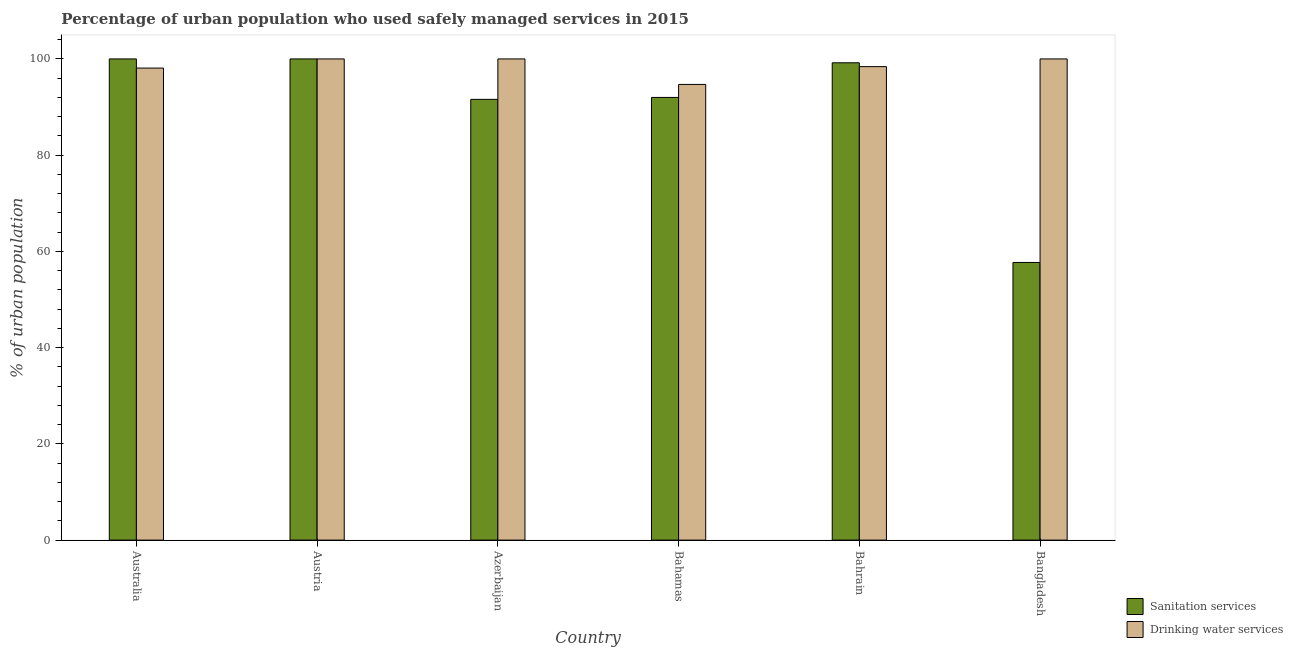How many groups of bars are there?
Make the answer very short. 6. How many bars are there on the 3rd tick from the left?
Offer a very short reply. 2. How many bars are there on the 5th tick from the right?
Give a very brief answer. 2. What is the label of the 3rd group of bars from the left?
Provide a succinct answer. Azerbaijan. What is the percentage of urban population who used drinking water services in Austria?
Offer a very short reply. 100. Across all countries, what is the maximum percentage of urban population who used sanitation services?
Give a very brief answer. 100. Across all countries, what is the minimum percentage of urban population who used sanitation services?
Provide a short and direct response. 57.7. In which country was the percentage of urban population who used sanitation services maximum?
Your answer should be compact. Australia. What is the total percentage of urban population who used sanitation services in the graph?
Ensure brevity in your answer.  540.5. What is the difference between the percentage of urban population who used sanitation services in Australia and that in Bangladesh?
Your answer should be compact. 42.3. What is the difference between the percentage of urban population who used drinking water services in Bangladesh and the percentage of urban population who used sanitation services in Bahamas?
Provide a short and direct response. 8. What is the average percentage of urban population who used sanitation services per country?
Provide a short and direct response. 90.08. What is the difference between the percentage of urban population who used sanitation services and percentage of urban population who used drinking water services in Austria?
Keep it short and to the point. 0. In how many countries, is the percentage of urban population who used drinking water services greater than 20 %?
Make the answer very short. 6. What is the ratio of the percentage of urban population who used sanitation services in Austria to that in Azerbaijan?
Your answer should be very brief. 1.09. Is the percentage of urban population who used sanitation services in Azerbaijan less than that in Bahrain?
Keep it short and to the point. Yes. What is the difference between the highest and the second highest percentage of urban population who used drinking water services?
Your answer should be very brief. 0. What is the difference between the highest and the lowest percentage of urban population who used drinking water services?
Your answer should be compact. 5.3. In how many countries, is the percentage of urban population who used drinking water services greater than the average percentage of urban population who used drinking water services taken over all countries?
Your answer should be very brief. 3. Is the sum of the percentage of urban population who used drinking water services in Australia and Bahamas greater than the maximum percentage of urban population who used sanitation services across all countries?
Your response must be concise. Yes. What does the 2nd bar from the left in Bahrain represents?
Ensure brevity in your answer.  Drinking water services. What does the 1st bar from the right in Azerbaijan represents?
Offer a very short reply. Drinking water services. Are all the bars in the graph horizontal?
Offer a very short reply. No. How many countries are there in the graph?
Provide a succinct answer. 6. What is the difference between two consecutive major ticks on the Y-axis?
Provide a succinct answer. 20. Are the values on the major ticks of Y-axis written in scientific E-notation?
Make the answer very short. No. Where does the legend appear in the graph?
Offer a very short reply. Bottom right. What is the title of the graph?
Your response must be concise. Percentage of urban population who used safely managed services in 2015. Does "Highest 10% of population" appear as one of the legend labels in the graph?
Provide a succinct answer. No. What is the label or title of the X-axis?
Keep it short and to the point. Country. What is the label or title of the Y-axis?
Keep it short and to the point. % of urban population. What is the % of urban population in Drinking water services in Australia?
Provide a succinct answer. 98.1. What is the % of urban population of Sanitation services in Austria?
Make the answer very short. 100. What is the % of urban population in Drinking water services in Austria?
Keep it short and to the point. 100. What is the % of urban population of Sanitation services in Azerbaijan?
Provide a succinct answer. 91.6. What is the % of urban population in Drinking water services in Azerbaijan?
Offer a very short reply. 100. What is the % of urban population of Sanitation services in Bahamas?
Make the answer very short. 92. What is the % of urban population in Drinking water services in Bahamas?
Offer a terse response. 94.7. What is the % of urban population in Sanitation services in Bahrain?
Give a very brief answer. 99.2. What is the % of urban population of Drinking water services in Bahrain?
Your response must be concise. 98.4. What is the % of urban population in Sanitation services in Bangladesh?
Provide a short and direct response. 57.7. What is the % of urban population of Drinking water services in Bangladesh?
Offer a very short reply. 100. Across all countries, what is the minimum % of urban population of Sanitation services?
Ensure brevity in your answer.  57.7. Across all countries, what is the minimum % of urban population in Drinking water services?
Your answer should be very brief. 94.7. What is the total % of urban population of Sanitation services in the graph?
Provide a short and direct response. 540.5. What is the total % of urban population in Drinking water services in the graph?
Keep it short and to the point. 591.2. What is the difference between the % of urban population of Drinking water services in Australia and that in Azerbaijan?
Your response must be concise. -1.9. What is the difference between the % of urban population in Drinking water services in Australia and that in Bahamas?
Ensure brevity in your answer.  3.4. What is the difference between the % of urban population in Sanitation services in Australia and that in Bangladesh?
Keep it short and to the point. 42.3. What is the difference between the % of urban population of Drinking water services in Australia and that in Bangladesh?
Provide a short and direct response. -1.9. What is the difference between the % of urban population of Drinking water services in Austria and that in Azerbaijan?
Provide a short and direct response. 0. What is the difference between the % of urban population of Sanitation services in Austria and that in Bahrain?
Give a very brief answer. 0.8. What is the difference between the % of urban population of Drinking water services in Austria and that in Bahrain?
Your answer should be very brief. 1.6. What is the difference between the % of urban population in Sanitation services in Austria and that in Bangladesh?
Ensure brevity in your answer.  42.3. What is the difference between the % of urban population in Drinking water services in Austria and that in Bangladesh?
Your response must be concise. 0. What is the difference between the % of urban population in Drinking water services in Azerbaijan and that in Bahamas?
Your answer should be compact. 5.3. What is the difference between the % of urban population of Sanitation services in Azerbaijan and that in Bangladesh?
Give a very brief answer. 33.9. What is the difference between the % of urban population in Sanitation services in Bahamas and that in Bahrain?
Your response must be concise. -7.2. What is the difference between the % of urban population in Sanitation services in Bahamas and that in Bangladesh?
Provide a succinct answer. 34.3. What is the difference between the % of urban population in Sanitation services in Bahrain and that in Bangladesh?
Give a very brief answer. 41.5. What is the difference between the % of urban population of Sanitation services in Australia and the % of urban population of Drinking water services in Azerbaijan?
Keep it short and to the point. 0. What is the difference between the % of urban population of Sanitation services in Australia and the % of urban population of Drinking water services in Bangladesh?
Make the answer very short. 0. What is the difference between the % of urban population of Sanitation services in Austria and the % of urban population of Drinking water services in Azerbaijan?
Give a very brief answer. 0. What is the difference between the % of urban population in Sanitation services in Austria and the % of urban population in Drinking water services in Bahamas?
Your answer should be very brief. 5.3. What is the difference between the % of urban population in Sanitation services in Azerbaijan and the % of urban population in Drinking water services in Bahrain?
Give a very brief answer. -6.8. What is the difference between the % of urban population in Sanitation services in Azerbaijan and the % of urban population in Drinking water services in Bangladesh?
Give a very brief answer. -8.4. What is the difference between the % of urban population in Sanitation services in Bahamas and the % of urban population in Drinking water services in Bahrain?
Offer a very short reply. -6.4. What is the difference between the % of urban population of Sanitation services in Bahamas and the % of urban population of Drinking water services in Bangladesh?
Your response must be concise. -8. What is the average % of urban population in Sanitation services per country?
Ensure brevity in your answer.  90.08. What is the average % of urban population in Drinking water services per country?
Your answer should be very brief. 98.53. What is the difference between the % of urban population in Sanitation services and % of urban population in Drinking water services in Austria?
Make the answer very short. 0. What is the difference between the % of urban population of Sanitation services and % of urban population of Drinking water services in Azerbaijan?
Your answer should be compact. -8.4. What is the difference between the % of urban population of Sanitation services and % of urban population of Drinking water services in Bangladesh?
Ensure brevity in your answer.  -42.3. What is the ratio of the % of urban population in Sanitation services in Australia to that in Austria?
Your answer should be compact. 1. What is the ratio of the % of urban population in Drinking water services in Australia to that in Austria?
Give a very brief answer. 0.98. What is the ratio of the % of urban population in Sanitation services in Australia to that in Azerbaijan?
Your answer should be very brief. 1.09. What is the ratio of the % of urban population of Sanitation services in Australia to that in Bahamas?
Your answer should be compact. 1.09. What is the ratio of the % of urban population of Drinking water services in Australia to that in Bahamas?
Provide a short and direct response. 1.04. What is the ratio of the % of urban population in Sanitation services in Australia to that in Bahrain?
Ensure brevity in your answer.  1.01. What is the ratio of the % of urban population of Drinking water services in Australia to that in Bahrain?
Offer a very short reply. 1. What is the ratio of the % of urban population of Sanitation services in Australia to that in Bangladesh?
Offer a very short reply. 1.73. What is the ratio of the % of urban population in Sanitation services in Austria to that in Azerbaijan?
Your answer should be very brief. 1.09. What is the ratio of the % of urban population in Drinking water services in Austria to that in Azerbaijan?
Ensure brevity in your answer.  1. What is the ratio of the % of urban population in Sanitation services in Austria to that in Bahamas?
Provide a succinct answer. 1.09. What is the ratio of the % of urban population of Drinking water services in Austria to that in Bahamas?
Give a very brief answer. 1.06. What is the ratio of the % of urban population in Sanitation services in Austria to that in Bahrain?
Keep it short and to the point. 1.01. What is the ratio of the % of urban population in Drinking water services in Austria to that in Bahrain?
Your answer should be very brief. 1.02. What is the ratio of the % of urban population in Sanitation services in Austria to that in Bangladesh?
Provide a short and direct response. 1.73. What is the ratio of the % of urban population in Sanitation services in Azerbaijan to that in Bahamas?
Offer a very short reply. 1. What is the ratio of the % of urban population in Drinking water services in Azerbaijan to that in Bahamas?
Provide a short and direct response. 1.06. What is the ratio of the % of urban population of Sanitation services in Azerbaijan to that in Bahrain?
Your answer should be very brief. 0.92. What is the ratio of the % of urban population in Drinking water services in Azerbaijan to that in Bahrain?
Offer a very short reply. 1.02. What is the ratio of the % of urban population in Sanitation services in Azerbaijan to that in Bangladesh?
Provide a succinct answer. 1.59. What is the ratio of the % of urban population of Drinking water services in Azerbaijan to that in Bangladesh?
Your answer should be very brief. 1. What is the ratio of the % of urban population of Sanitation services in Bahamas to that in Bahrain?
Ensure brevity in your answer.  0.93. What is the ratio of the % of urban population in Drinking water services in Bahamas to that in Bahrain?
Provide a succinct answer. 0.96. What is the ratio of the % of urban population in Sanitation services in Bahamas to that in Bangladesh?
Your answer should be compact. 1.59. What is the ratio of the % of urban population in Drinking water services in Bahamas to that in Bangladesh?
Offer a very short reply. 0.95. What is the ratio of the % of urban population in Sanitation services in Bahrain to that in Bangladesh?
Keep it short and to the point. 1.72. What is the ratio of the % of urban population in Drinking water services in Bahrain to that in Bangladesh?
Provide a succinct answer. 0.98. What is the difference between the highest and the lowest % of urban population in Sanitation services?
Your answer should be compact. 42.3. What is the difference between the highest and the lowest % of urban population of Drinking water services?
Offer a very short reply. 5.3. 